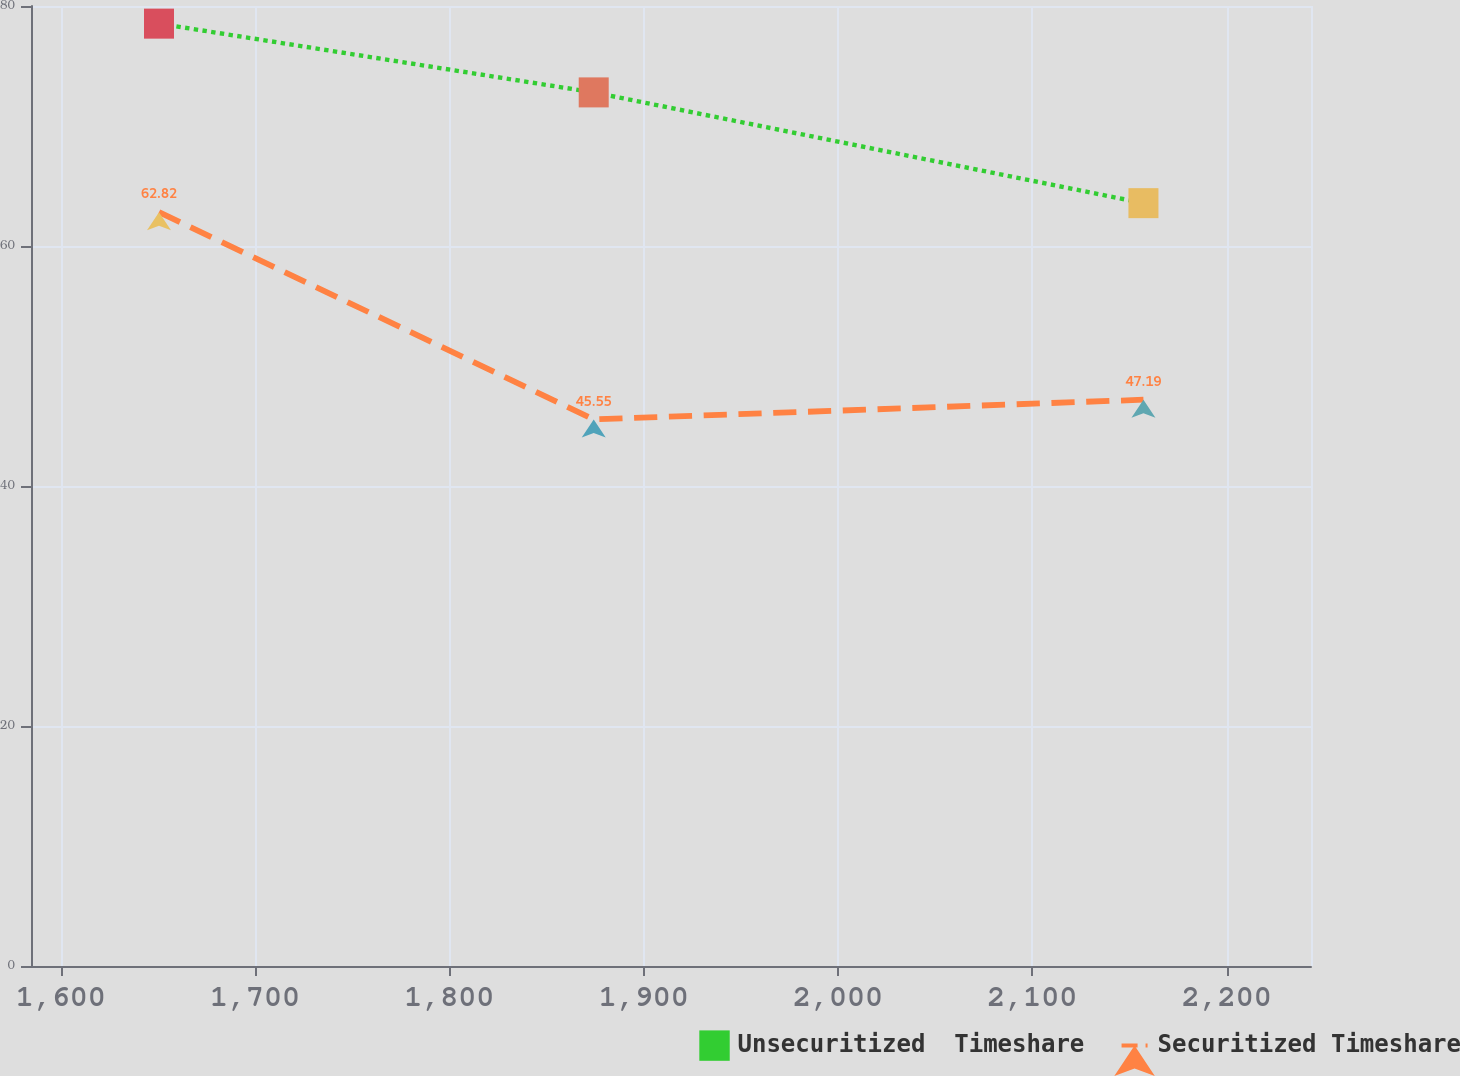<chart> <loc_0><loc_0><loc_500><loc_500><line_chart><ecel><fcel>Unsecuritized  Timeshare<fcel>Securitized Timeshare<nl><fcel>1650.6<fcel>78.53<fcel>62.82<nl><fcel>1874.3<fcel>72.8<fcel>45.55<nl><fcel>2157.18<fcel>63.57<fcel>47.19<nl><fcel>2248.18<fcel>61.79<fcel>64.46<nl><fcel>2309.27<fcel>76.87<fcel>61.18<nl></chart> 